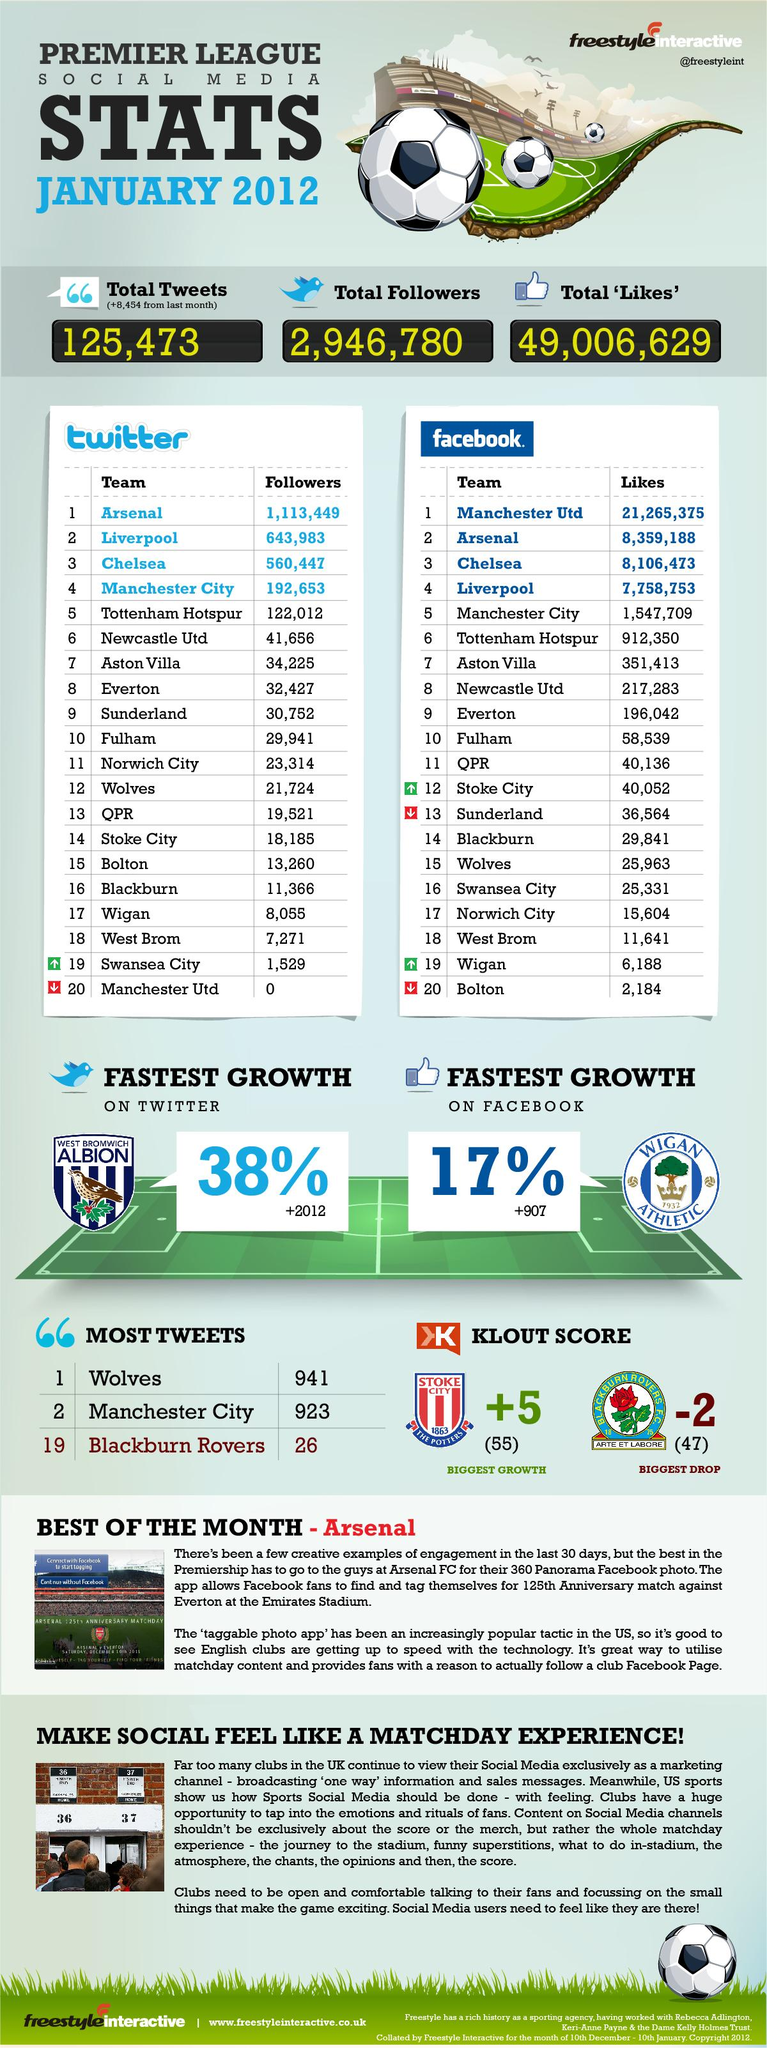Identify some key points in this picture. Manchester City is the football team that ranks fourth in terms of the number of followers and fifth in terms of the number of likes. Manchester United is the football club that has the most number of likes on Facebook but does not have any followers on Twitter. 